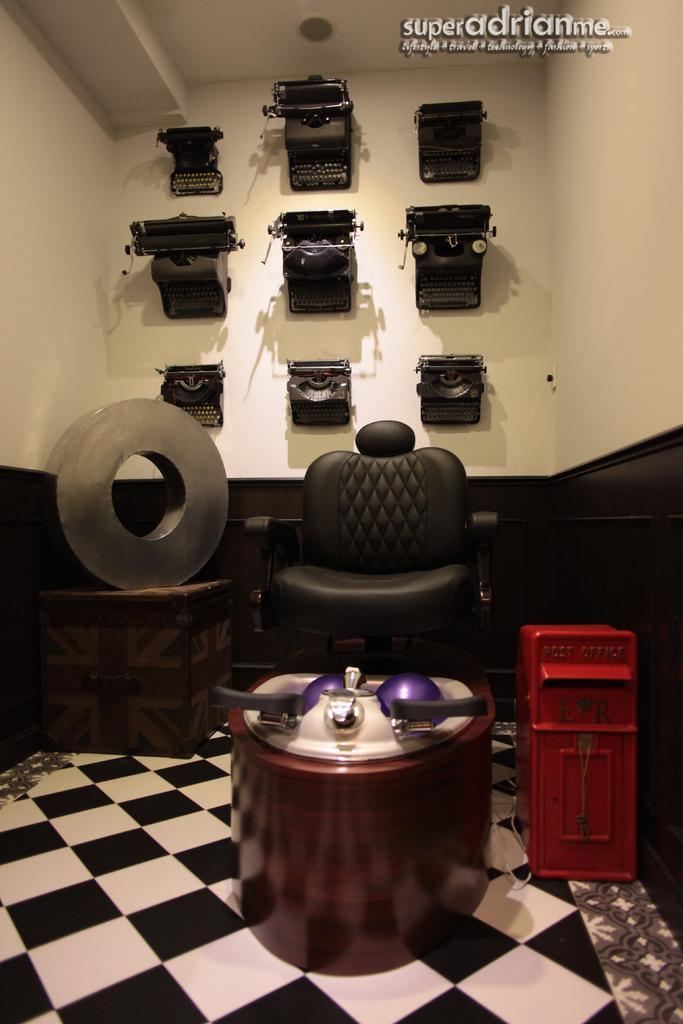Describe this image in one or two sentences. In the center of the image, we can see a chair and there are some objects on the stand. On the right, there is a box, which is in red color and we can see a wheel on the box and there are some electronic devices on the wall. At the top, there is some text written and at the bottom, there is floor. 